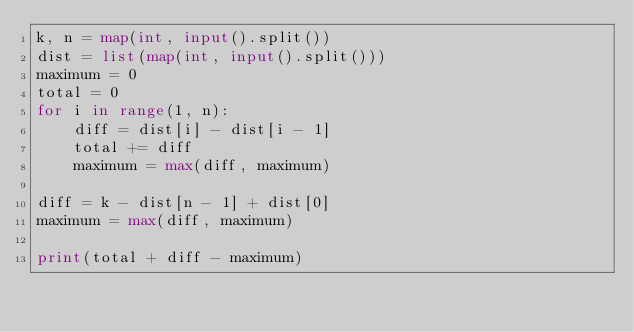<code> <loc_0><loc_0><loc_500><loc_500><_Python_>k, n = map(int, input().split())
dist = list(map(int, input().split()))
maximum = 0
total = 0
for i in range(1, n):
    diff = dist[i] - dist[i - 1]
    total += diff
    maximum = max(diff, maximum)

diff = k - dist[n - 1] + dist[0]
maximum = max(diff, maximum)

print(total + diff - maximum)</code> 